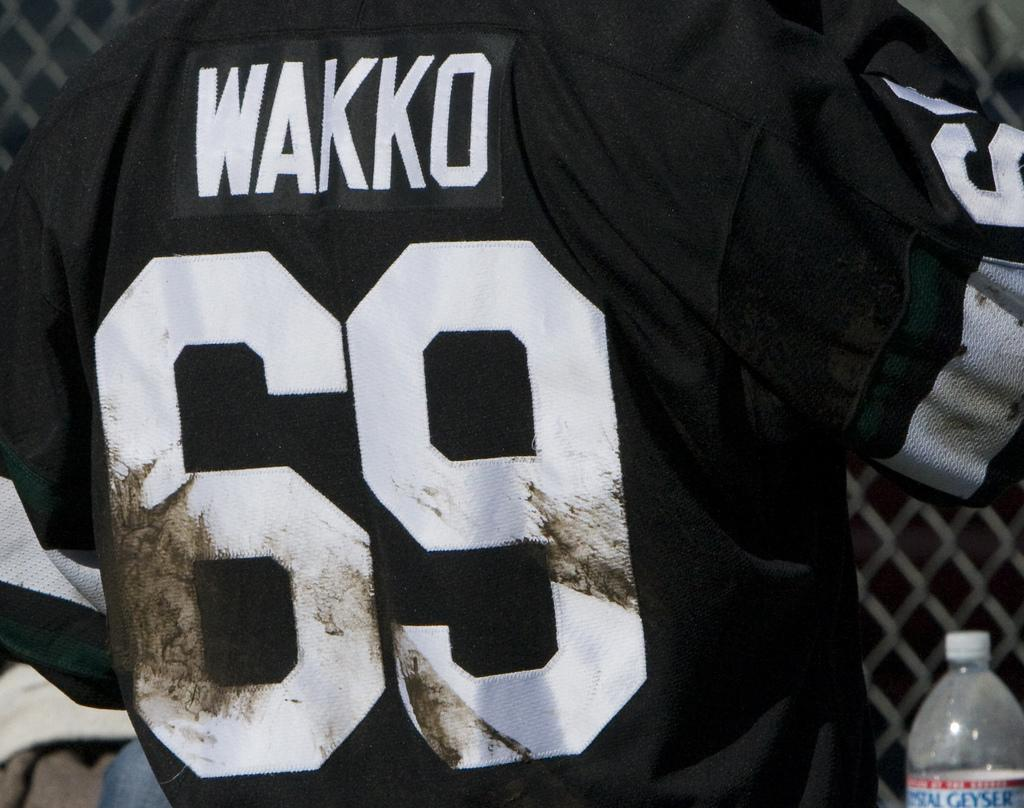<image>
Offer a succinct explanation of the picture presented. The back a of a jersey with Wakko and the number 69 on it. 